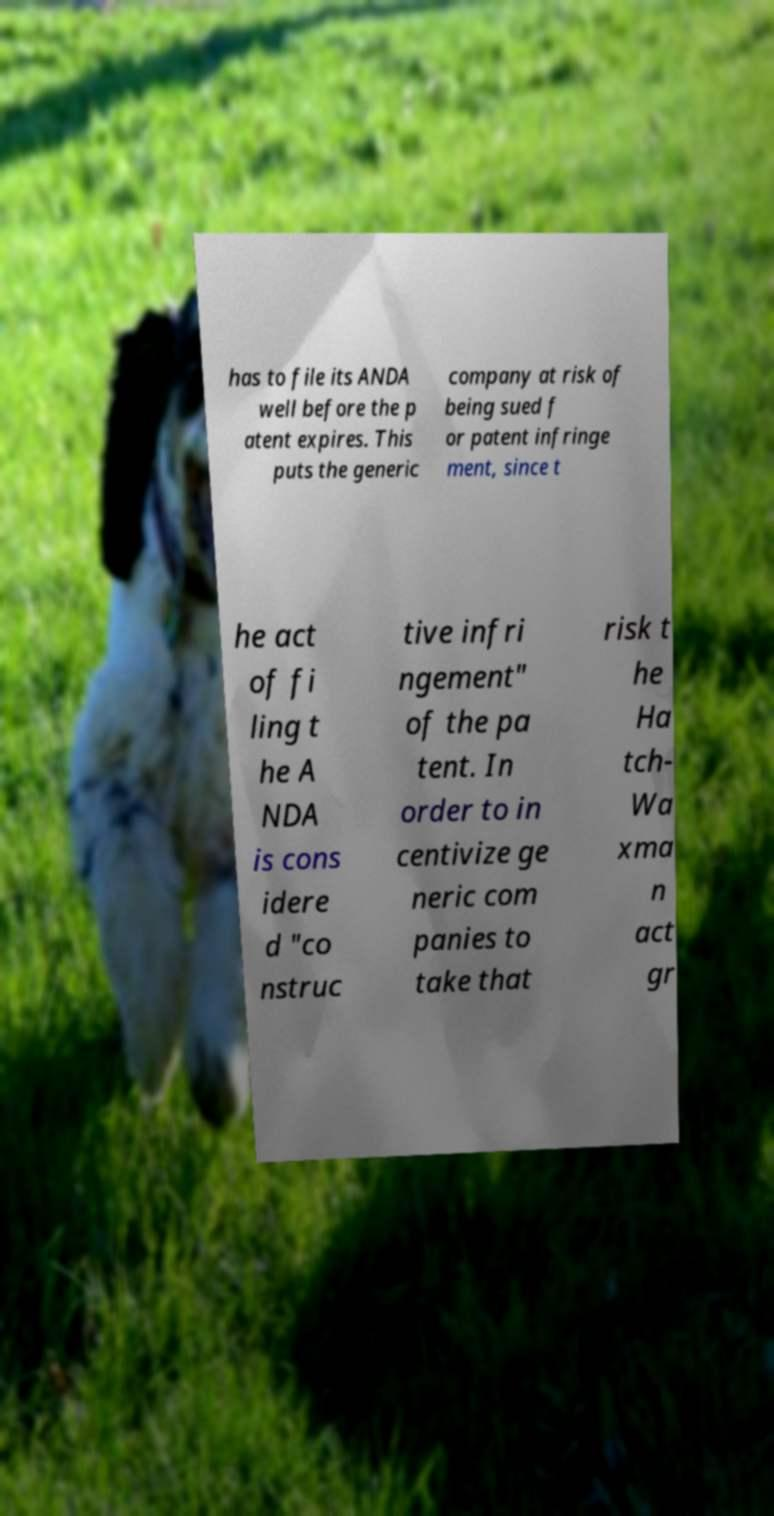Could you assist in decoding the text presented in this image and type it out clearly? has to file its ANDA well before the p atent expires. This puts the generic company at risk of being sued f or patent infringe ment, since t he act of fi ling t he A NDA is cons idere d "co nstruc tive infri ngement" of the pa tent. In order to in centivize ge neric com panies to take that risk t he Ha tch- Wa xma n act gr 